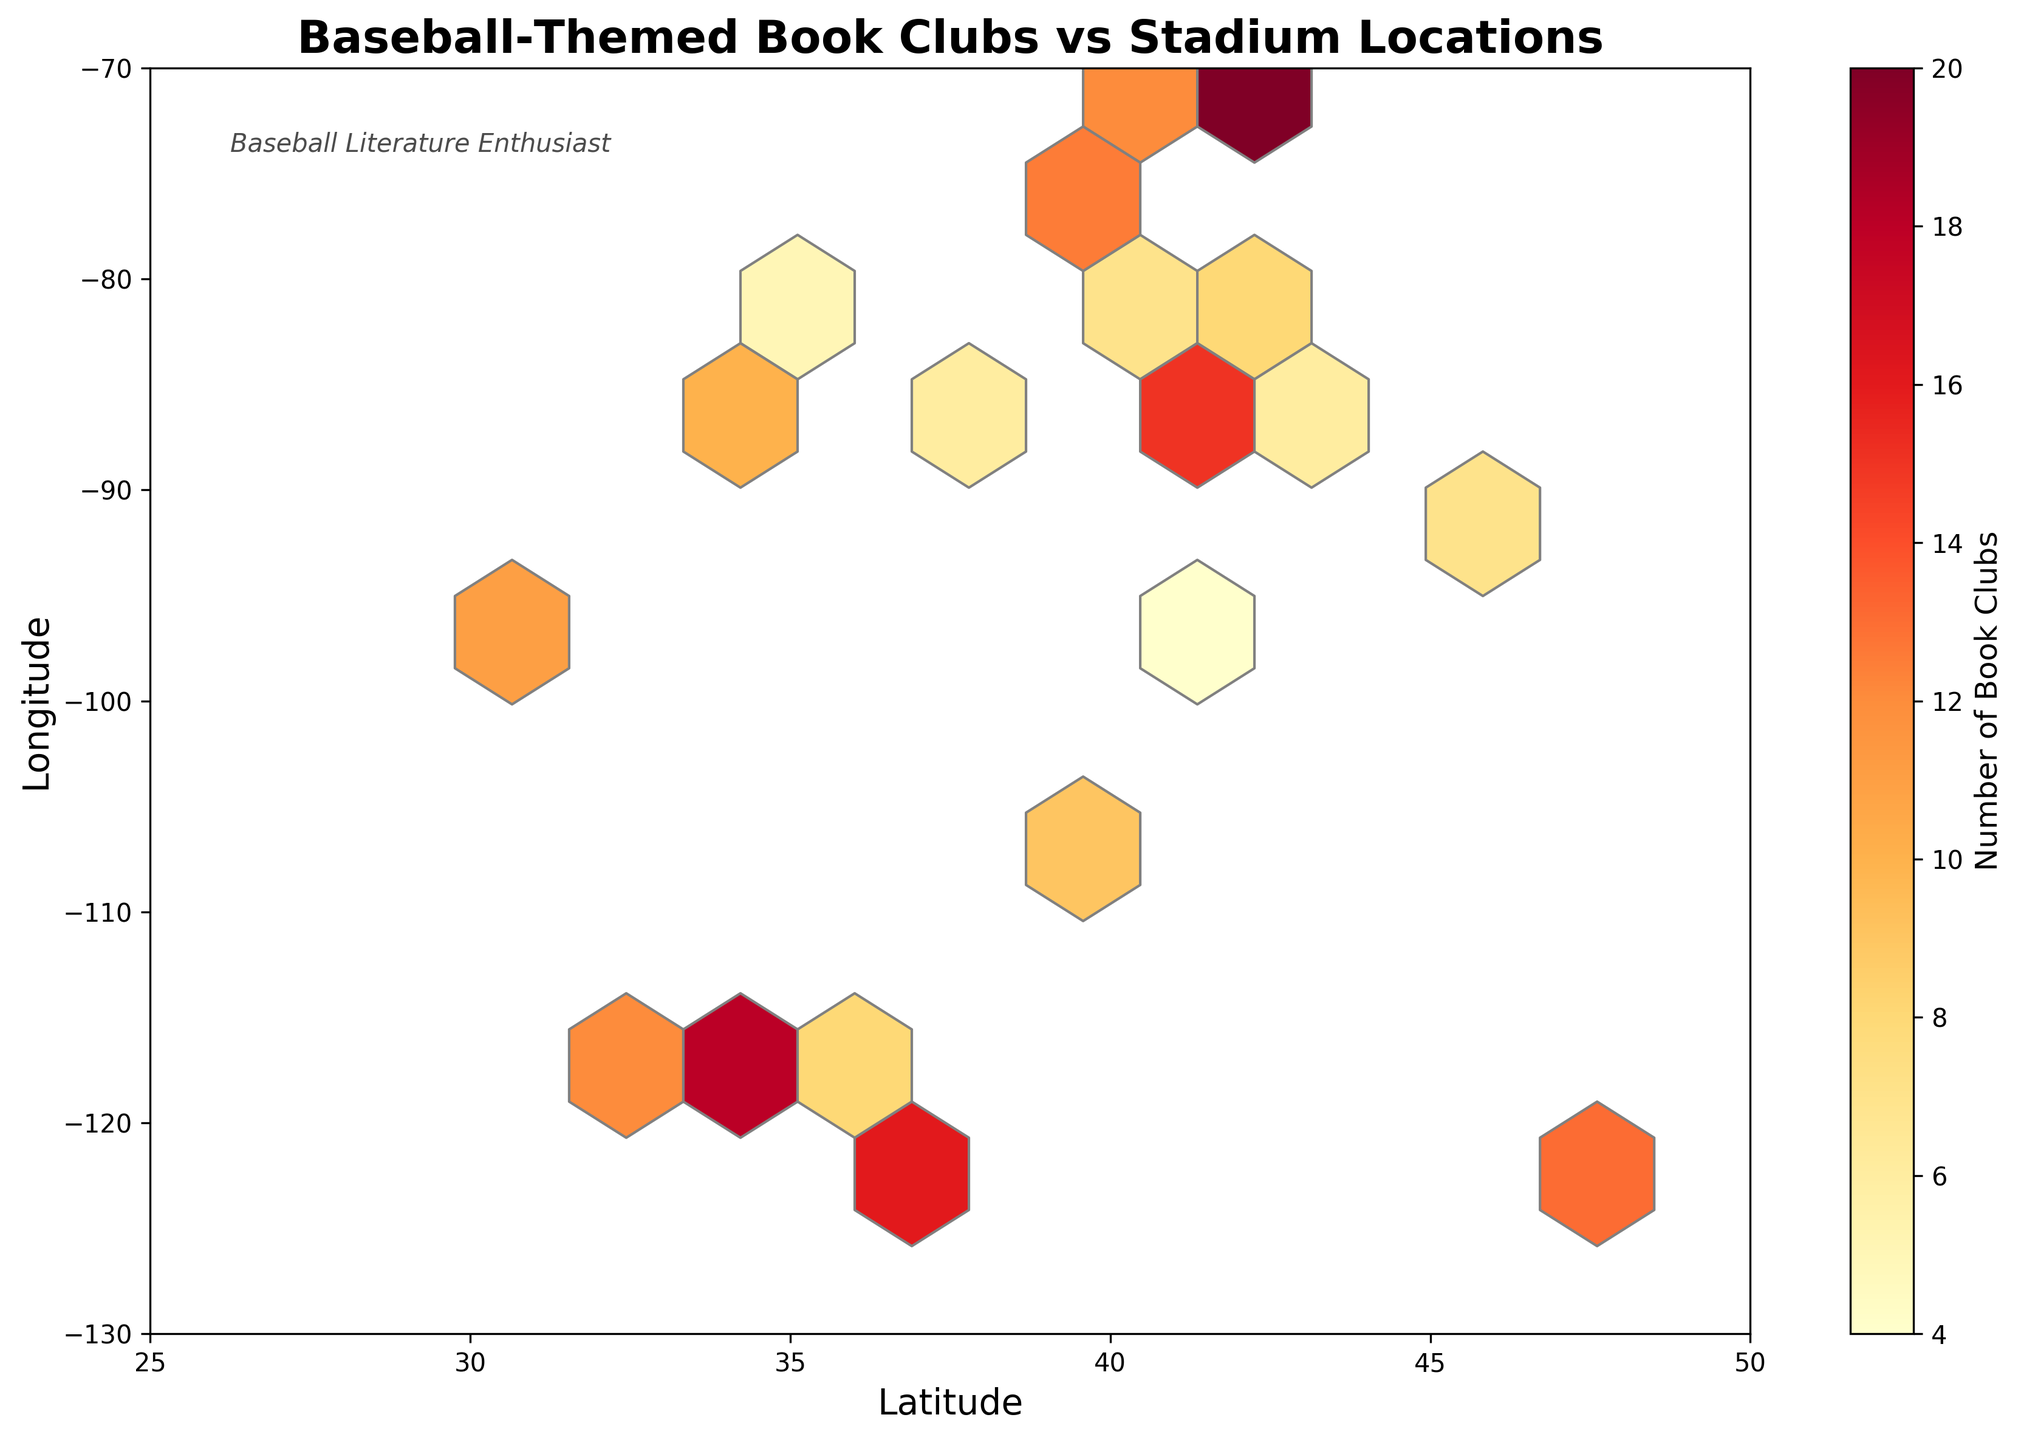What's the title of the figure? The title is usually placed at the top of the figure and is clearly visible. It conveys the main topic or insight shown in the hexbin plot.
Answer: Baseball-Themed Book Clubs vs Stadium Locations Which color represents the highest number of book clubs? By looking at the color scale (color bar) on the side, we observe that the darkest or most intense color typically represents the highest value on a hexbin plot.
Answer: Dark red What are the axis labels on the plot? The axis labels are usually placed near the axes and describe what each axis represents.
Answer: Latitude (x-axis), Longitude (y-axis) How many unique hexagons are there in the plot? By counting the number of visible hexagonal cells in the plotted area, we determine the total.
Answer: 6 (estimate based on visible plot) Which city is represented by the hexagon with the highest number of book clubs? By cross-referencing the color bar with the most intense color in the plot, we identify the hexagon with the maximum value. Looking into the data table, we match the value to the corresponding coordinates.
Answer: Boston (42.3601, -71.0589) with 20 book clubs What is the range of values on the color bar? The range of values on the color bar will be from the minimum to the maximum number of book clubs shown in the plot.
Answer: 4 to 20 What is the average number of book clubs across all cities? Sum up all the "value" entries in the data and divide by the number of cities. Calculation: (12 + 15 + 18 + 20 + 14 + 16 + 11 + 13 + 9 + 10 + 8 + 7 + 11 + 6 + 5 + 8 + 12 + 7 + 6 + 4)/20 = 11.15
Answer: 11.15 Which city has the lowest number of book clubs, and how is it represented in the plot? By identifying the minimum value in the data and then finding its corresponding coordinates in the hexbin plot, we identify both the city and its hexagon’s color. The lowest value is "4" corresponding to Omaha (41.2565, -95.9345).
Answer: Omaha (4 book clubs) How does a hexbin plot help in visualizing the correlation between two variables? A hexbin plot helps to visualize the density of data points in a given area by grouping them into hexagonal bins. The color indicates the number of occurrences within each bin, allowing one to discern patterns and correlations between the axes (latitude and longitude, in this case) and the third variable (number of book clubs).
Answer: Shows density and correlation 